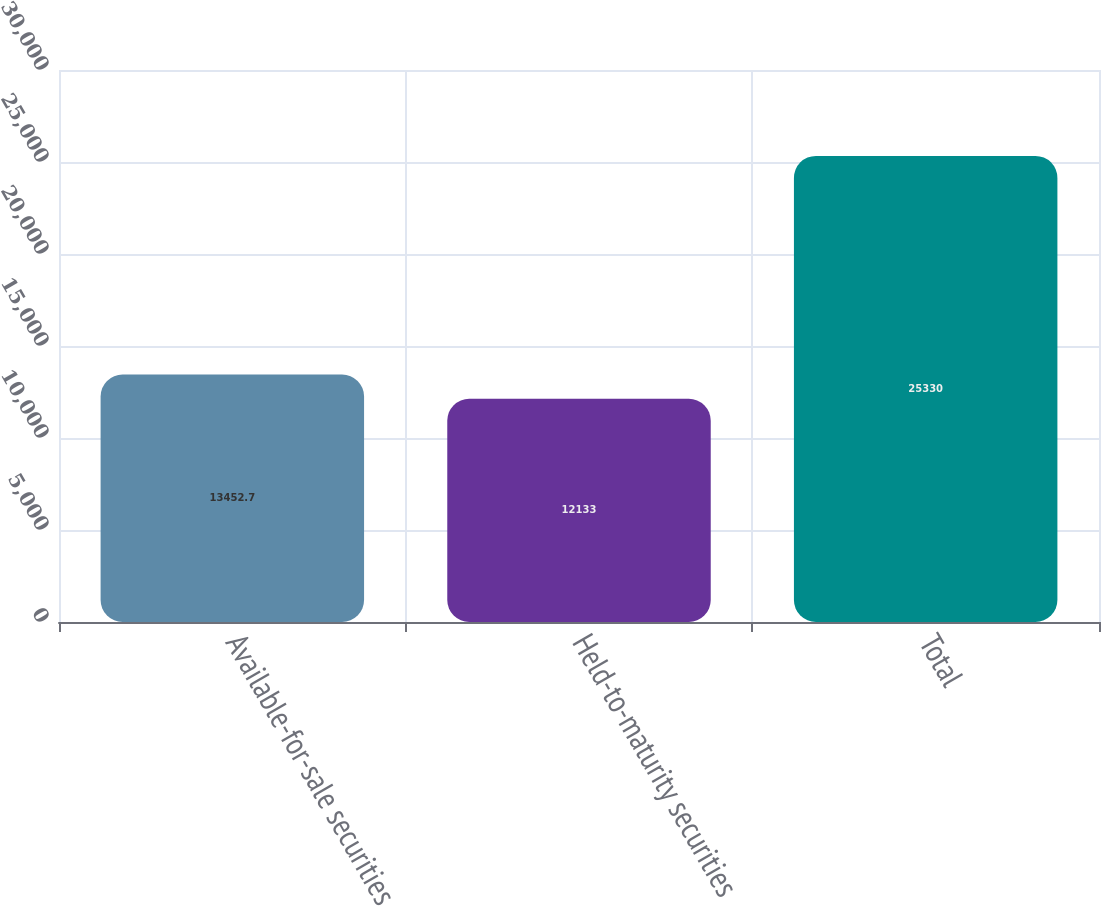<chart> <loc_0><loc_0><loc_500><loc_500><bar_chart><fcel>Available-for-sale securities<fcel>Held-to-maturity securities<fcel>Total<nl><fcel>13452.7<fcel>12133<fcel>25330<nl></chart> 